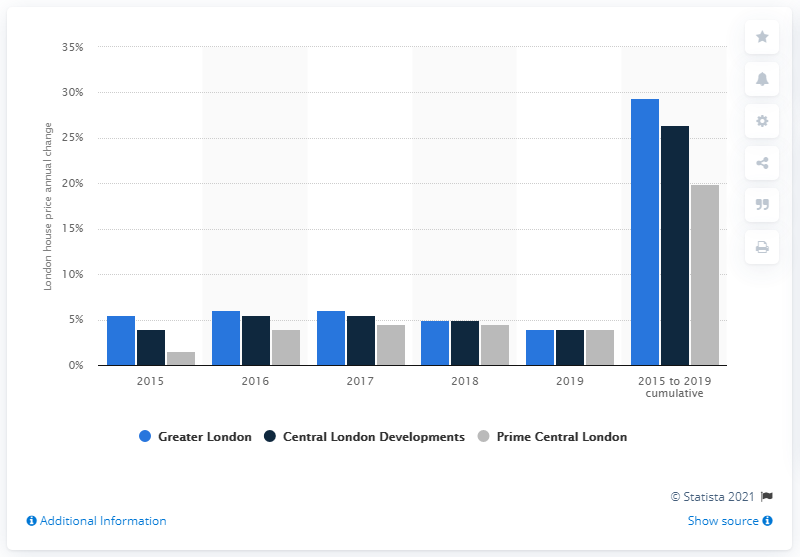Highlight a few significant elements in this photo. According to a study conducted between 2015 and 2019, the expected rate of house price growth in the Greater London area was estimated to be 29.4%. 